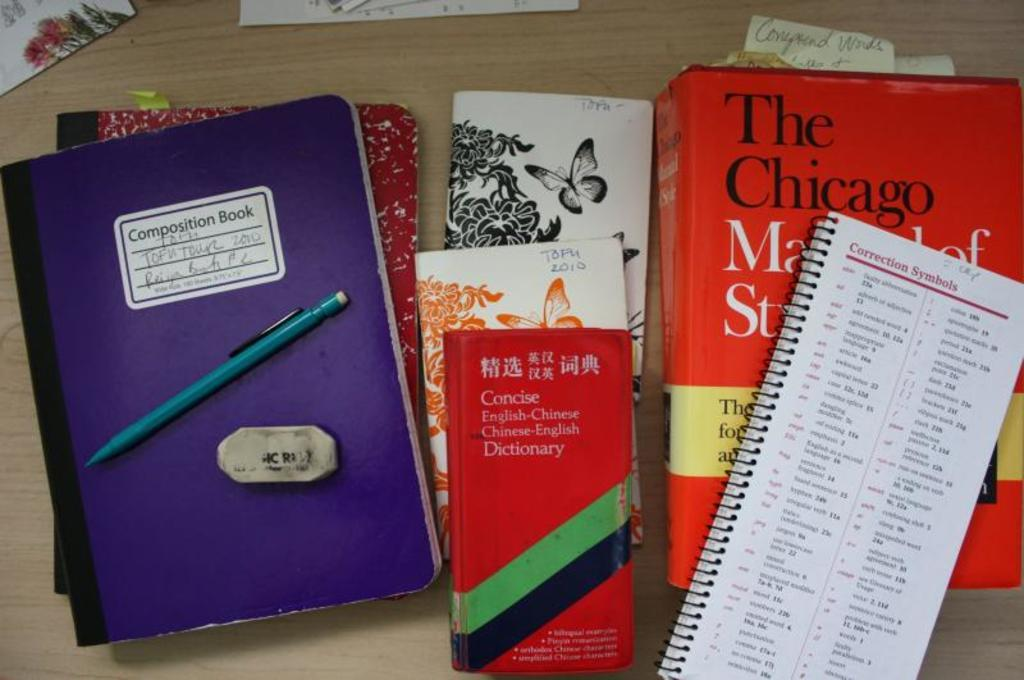<image>
Relay a brief, clear account of the picture shown. Various books and note pads on a wood surface including a chinese english dictionary. 